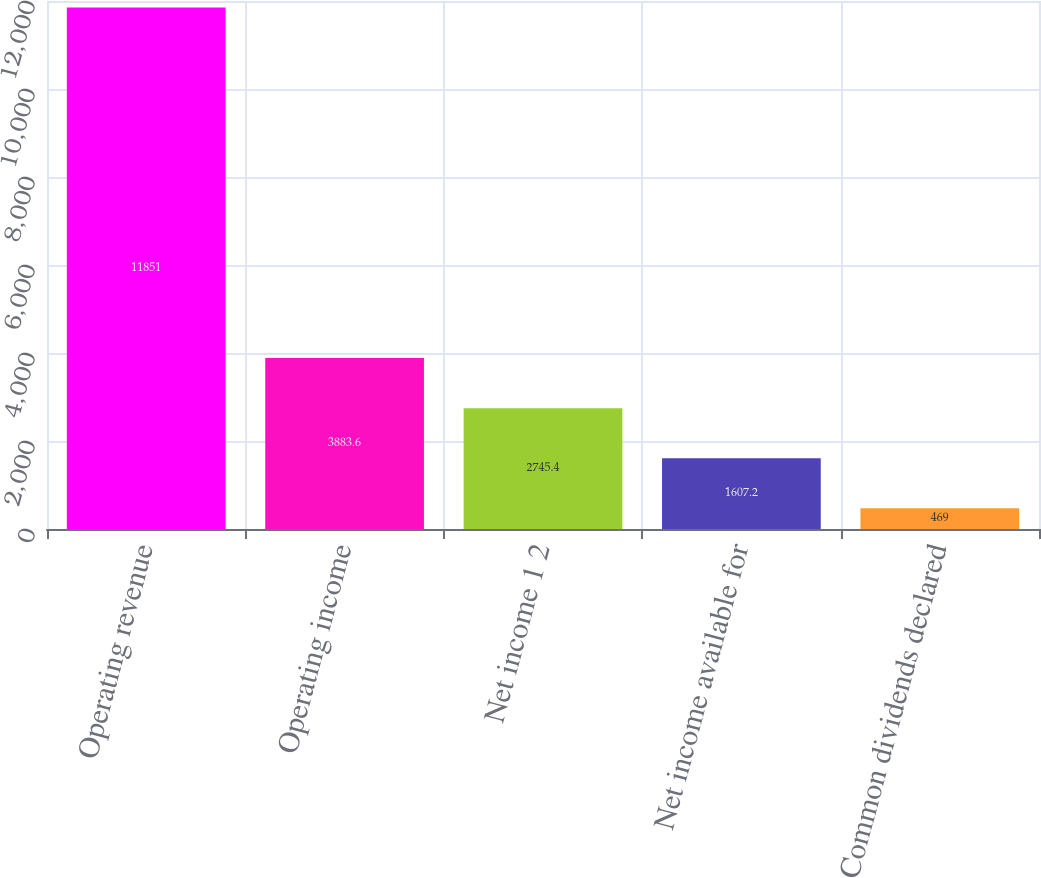Convert chart to OTSL. <chart><loc_0><loc_0><loc_500><loc_500><bar_chart><fcel>Operating revenue<fcel>Operating income<fcel>Net income 1 2<fcel>Net income available for<fcel>Common dividends declared<nl><fcel>11851<fcel>3883.6<fcel>2745.4<fcel>1607.2<fcel>469<nl></chart> 